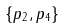<formula> <loc_0><loc_0><loc_500><loc_500>\{ p _ { 2 } , p _ { 4 } \}</formula> 